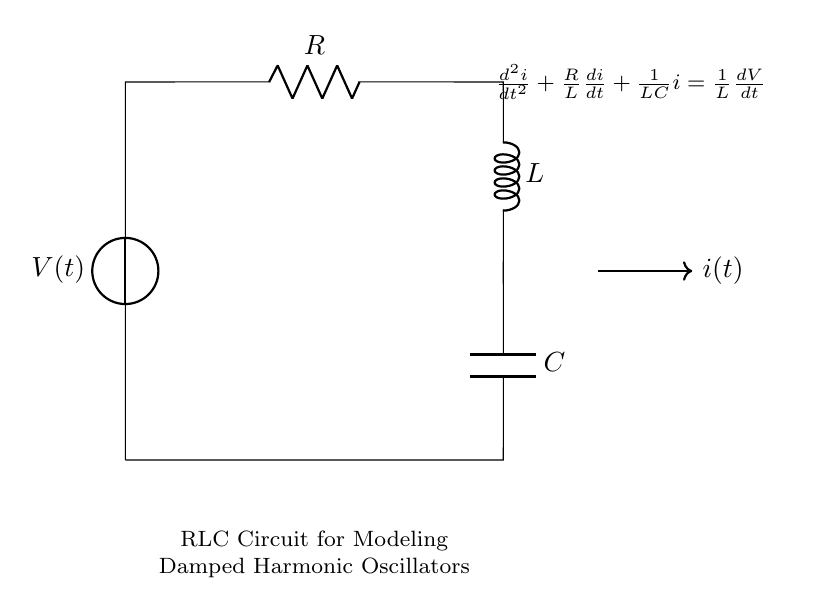What is the voltage source in this circuit? The voltage source is labeled as V(t), indicating it is a time-dependent voltage. This is typically used to represent varying voltage in circuits.
Answer: V(t) What is the value of the resistor in this circuit? The resistor is labeled as R. The circuit diagram does not provide a numerical value, so we refer to it as R, which denotes the resistance.
Answer: R What is the equation associated with this RLC circuit? The equation displayed is a second-order differential equation: d²i/dt² + (R/L)di/dt + (1/LC)i = (1/L)dV/dt. This describes the dynamics of current i(t) in the circuit.
Answer: d²i/dt² + (R/L)di/dt + (1/LC)i = (1/L)dV/dt How does the circuit behave if the resistance R approaches zero? As R approaches zero, the term (R/L)di/dt in the equation diminishes, leading to less damping in the system. This change implies that the oscillations would behave closer to an undamped harmonic oscillator.
Answer: Less damping What is the role of the inductor in this RLC circuit? The inductor, labeled L, stores energy in its magnetic field when current flows through it and resists changes in that current, contributing to the oscillatory behavior of the circuit.
Answer: Store energy What type of oscillation is represented in this system? The oscillation represented is damped harmonic oscillation, where energy is lost over time due to resistance, causing the amplitude of oscillation to decrease.
Answer: Damped harmonic oscillation What is the function of the capacitor in this circuit? The capacitor, labeled C, stores energy in the form of an electric field and releases it, contributing to the charge/discharge cycle that characterizes oscillatory circuits like this one.
Answer: Store energy 